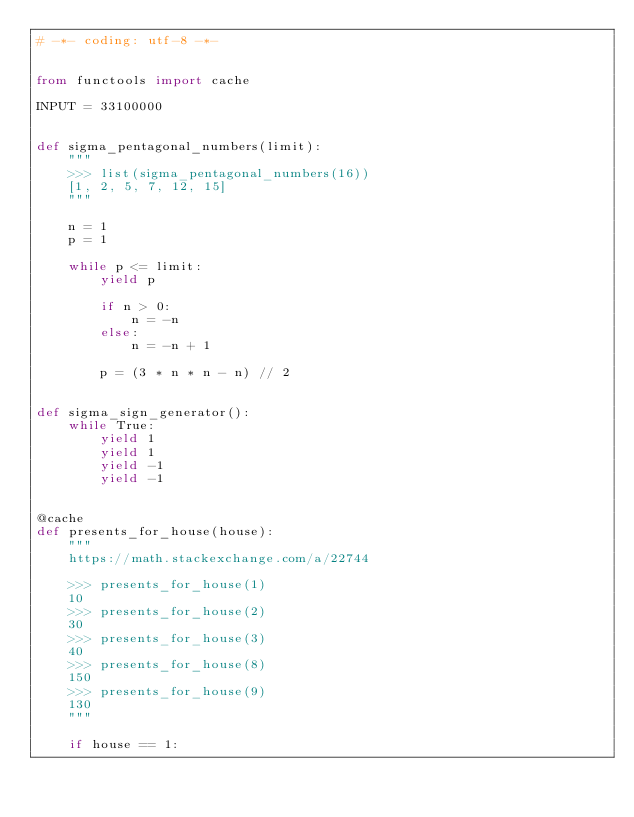Convert code to text. <code><loc_0><loc_0><loc_500><loc_500><_Python_># -*- coding: utf-8 -*-


from functools import cache

INPUT = 33100000


def sigma_pentagonal_numbers(limit):
    """
    >>> list(sigma_pentagonal_numbers(16))
    [1, 2, 5, 7, 12, 15]
    """

    n = 1
    p = 1

    while p <= limit:
        yield p

        if n > 0:
            n = -n
        else:
            n = -n + 1

        p = (3 * n * n - n) // 2


def sigma_sign_generator():
    while True:
        yield 1
        yield 1
        yield -1
        yield -1


@cache
def presents_for_house(house):
    """
    https://math.stackexchange.com/a/22744

    >>> presents_for_house(1)
    10
    >>> presents_for_house(2)
    30
    >>> presents_for_house(3)
    40
    >>> presents_for_house(8)
    150
    >>> presents_for_house(9)
    130
    """

    if house == 1:</code> 